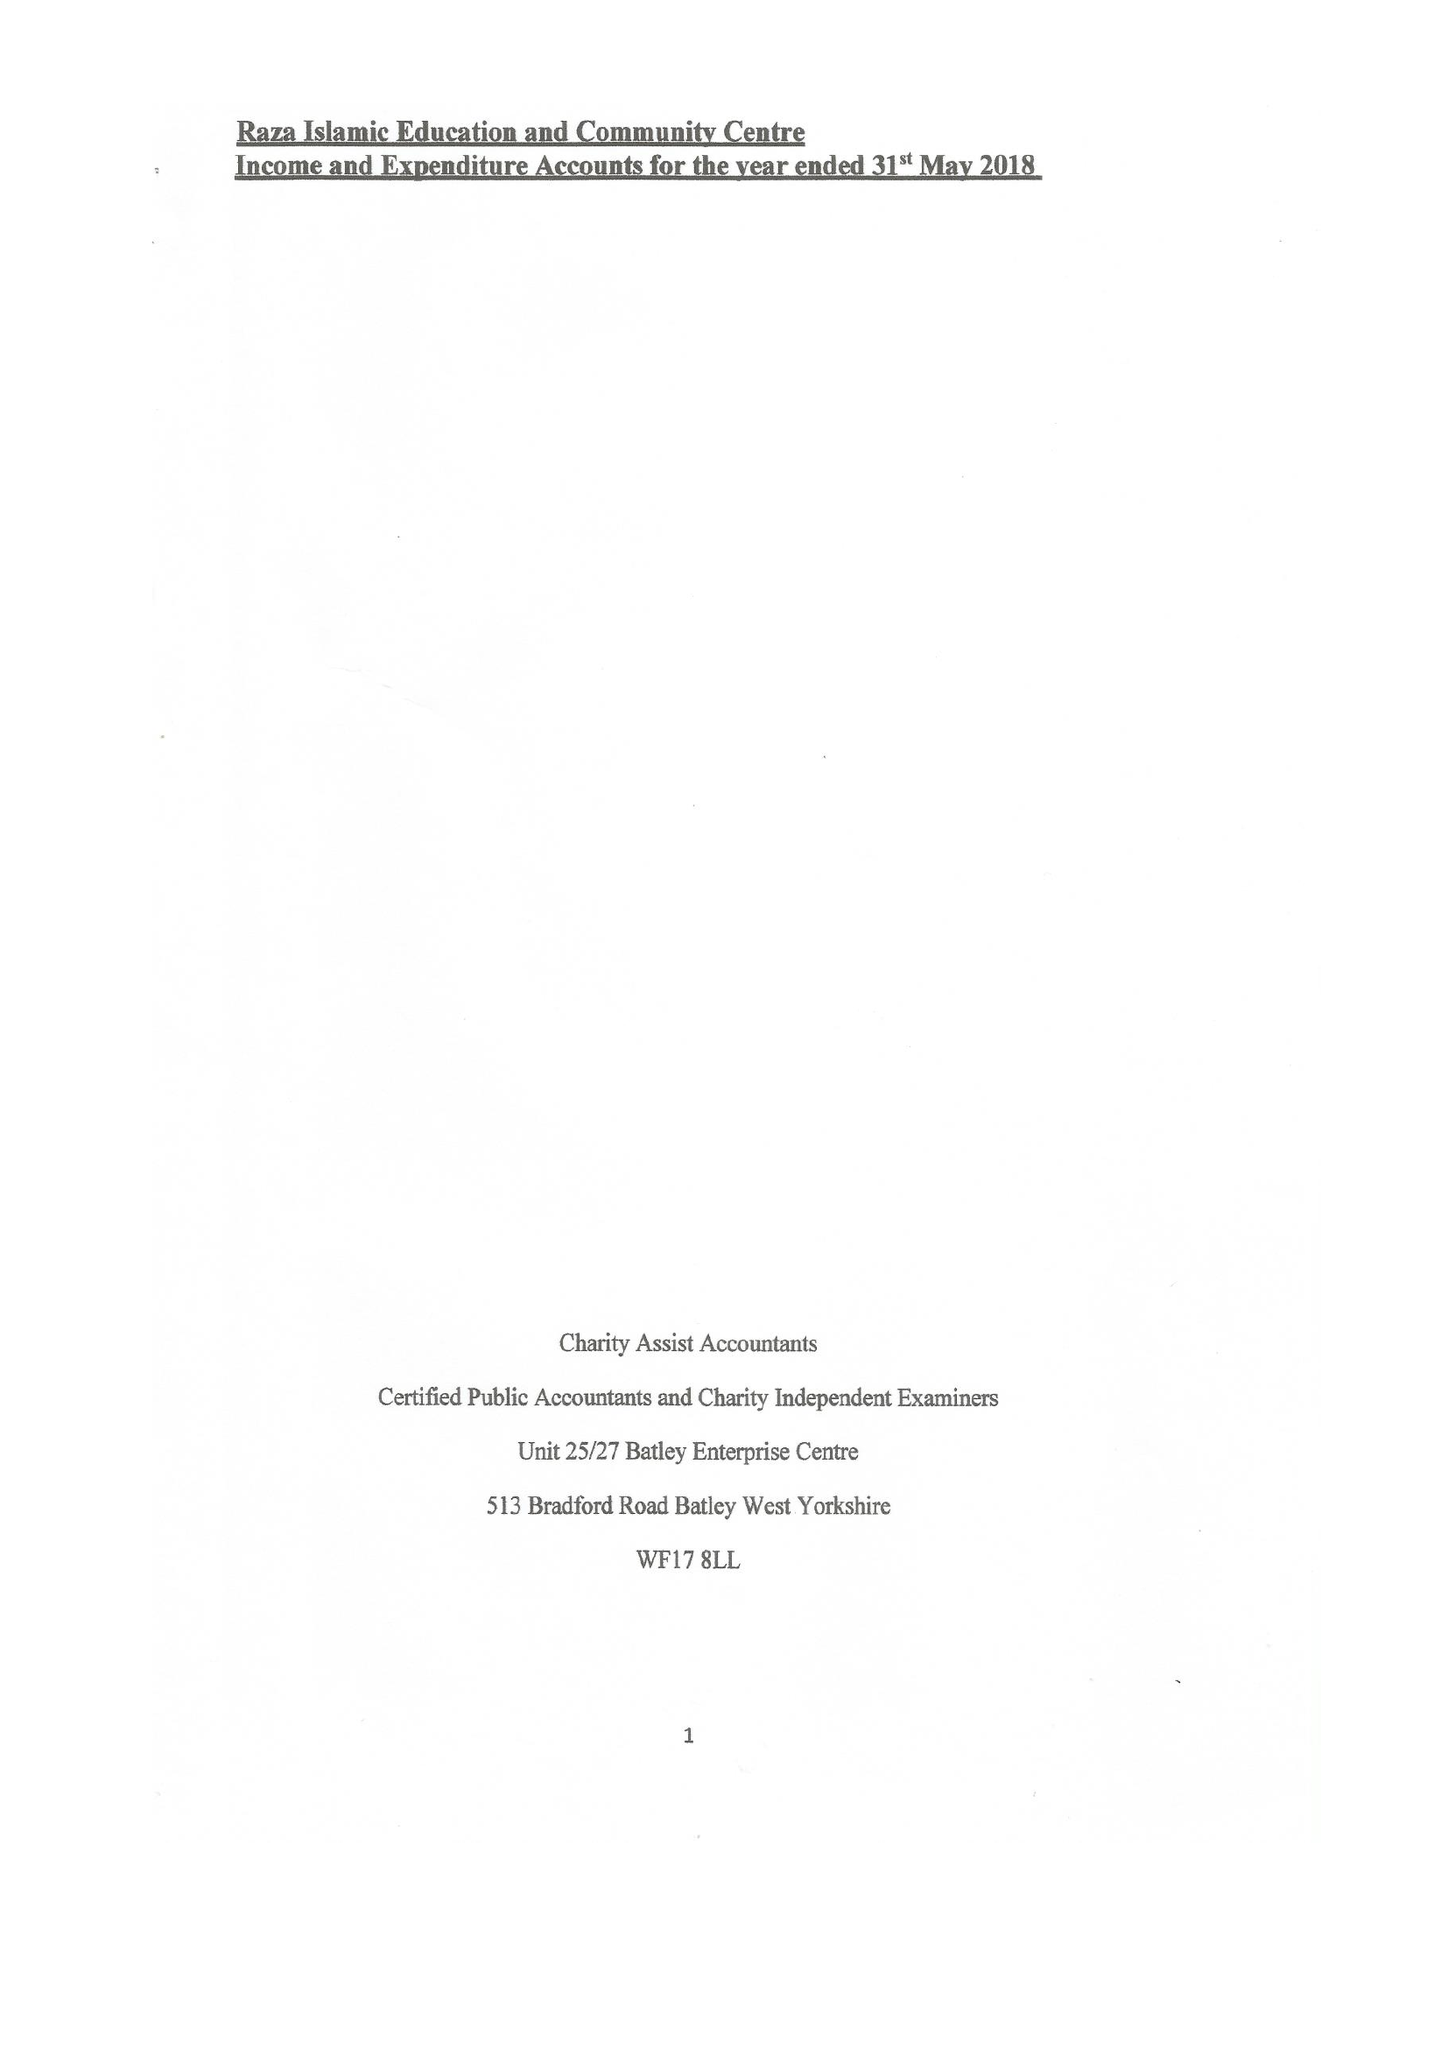What is the value for the charity_name?
Answer the question using a single word or phrase. Raza Islamic Education and Community Centre 